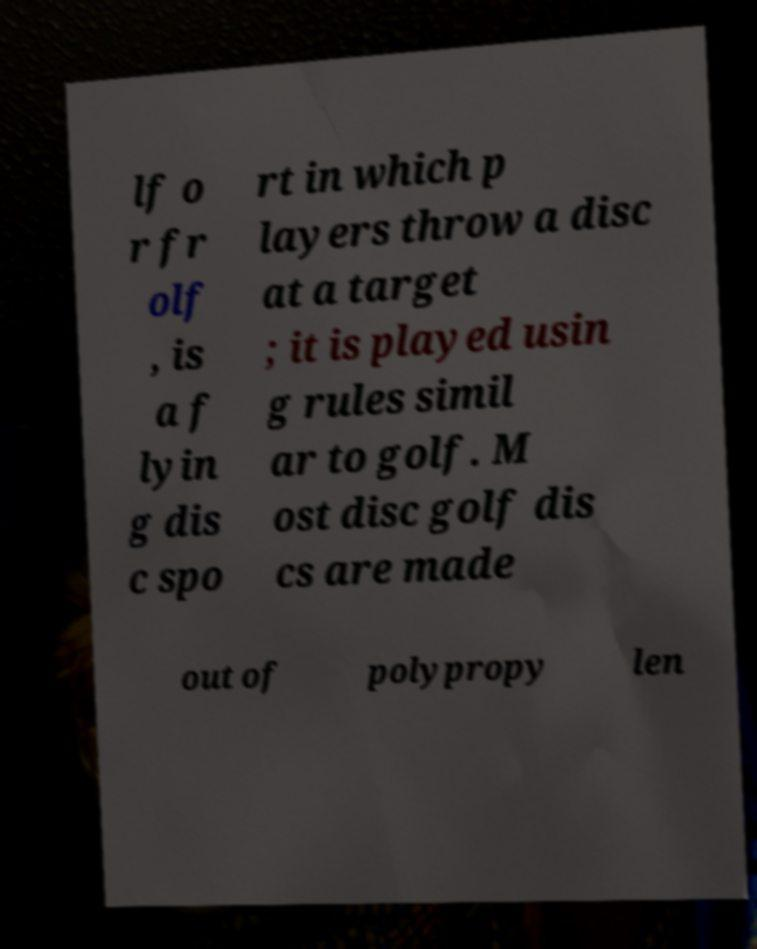There's text embedded in this image that I need extracted. Can you transcribe it verbatim? lf o r fr olf , is a f lyin g dis c spo rt in which p layers throw a disc at a target ; it is played usin g rules simil ar to golf. M ost disc golf dis cs are made out of polypropy len 